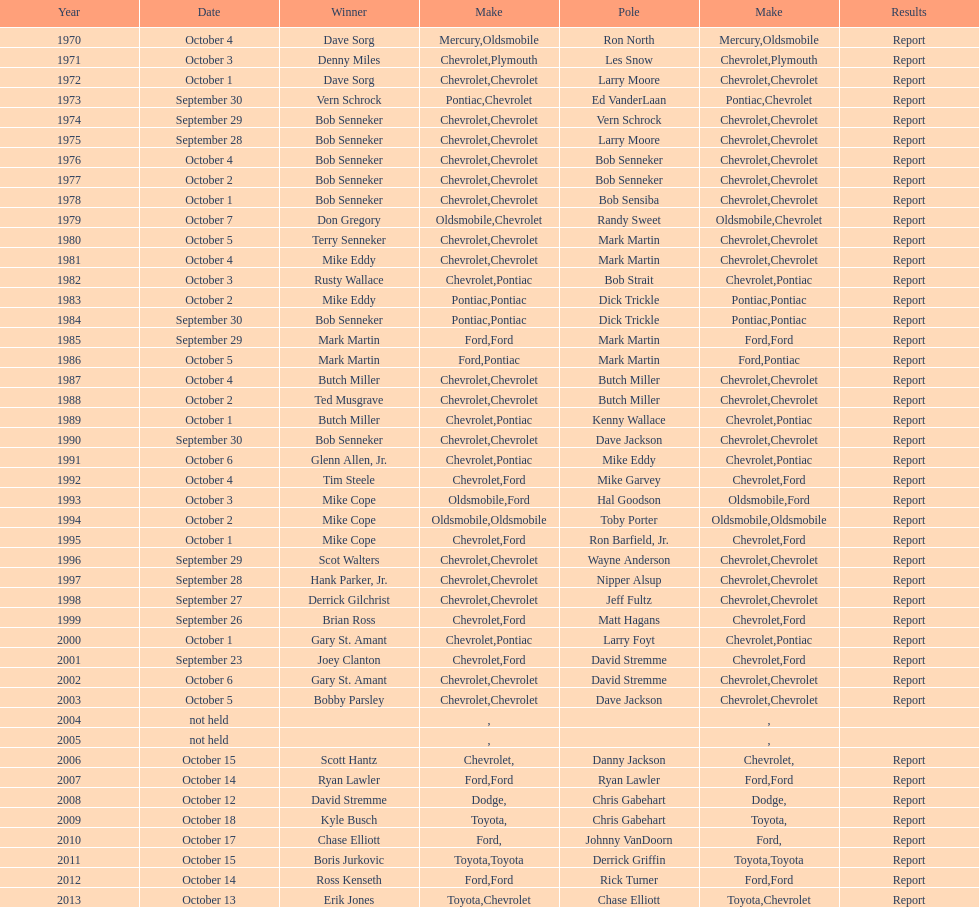How many consecutive wins did bob senneker have? 5. 